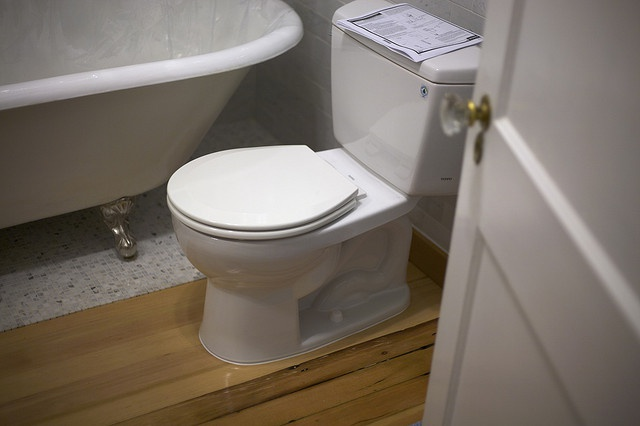Describe the objects in this image and their specific colors. I can see a toilet in gray, darkgray, and lightgray tones in this image. 